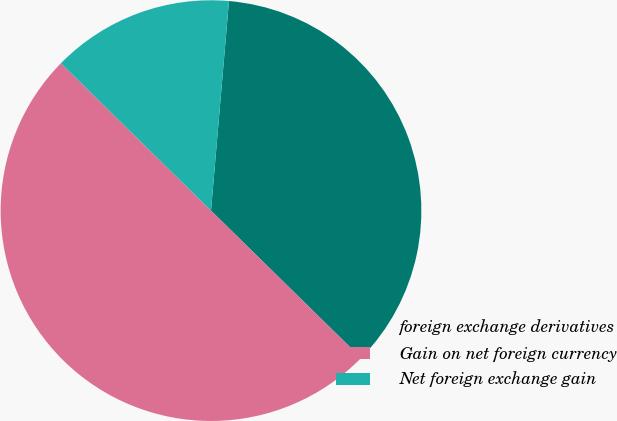Convert chart to OTSL. <chart><loc_0><loc_0><loc_500><loc_500><pie_chart><fcel>foreign exchange derivatives<fcel>Gain on net foreign currency<fcel>Net foreign exchange gain<nl><fcel>35.99%<fcel>50.0%<fcel>14.01%<nl></chart> 